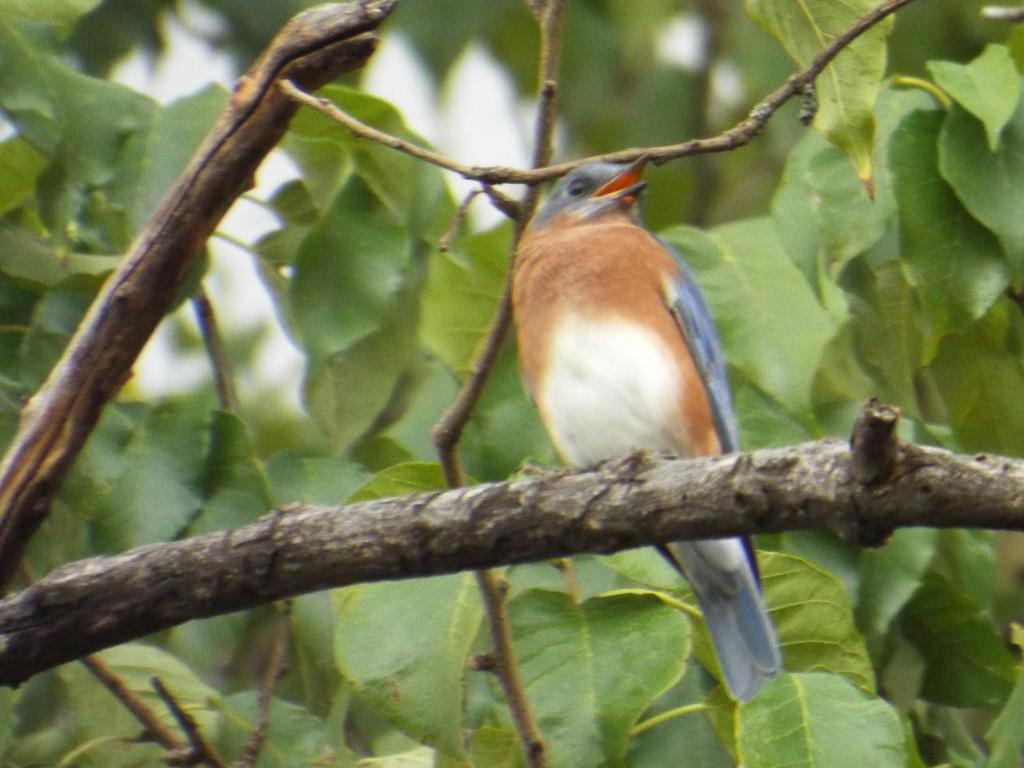What type of animal can be seen in the image? There is a bird in the image. Where is the bird located in the image? The bird is sitting on a branch. What can be observed about the leaves in the image? There are green color leaves in the image. What type of punishment is being administered to the bird in the image? There is no punishment being administered to the bird in the image; it is simply sitting on a branch. What kind of border can be seen surrounding the image? The provided facts do not mention any borders surrounding the image. 